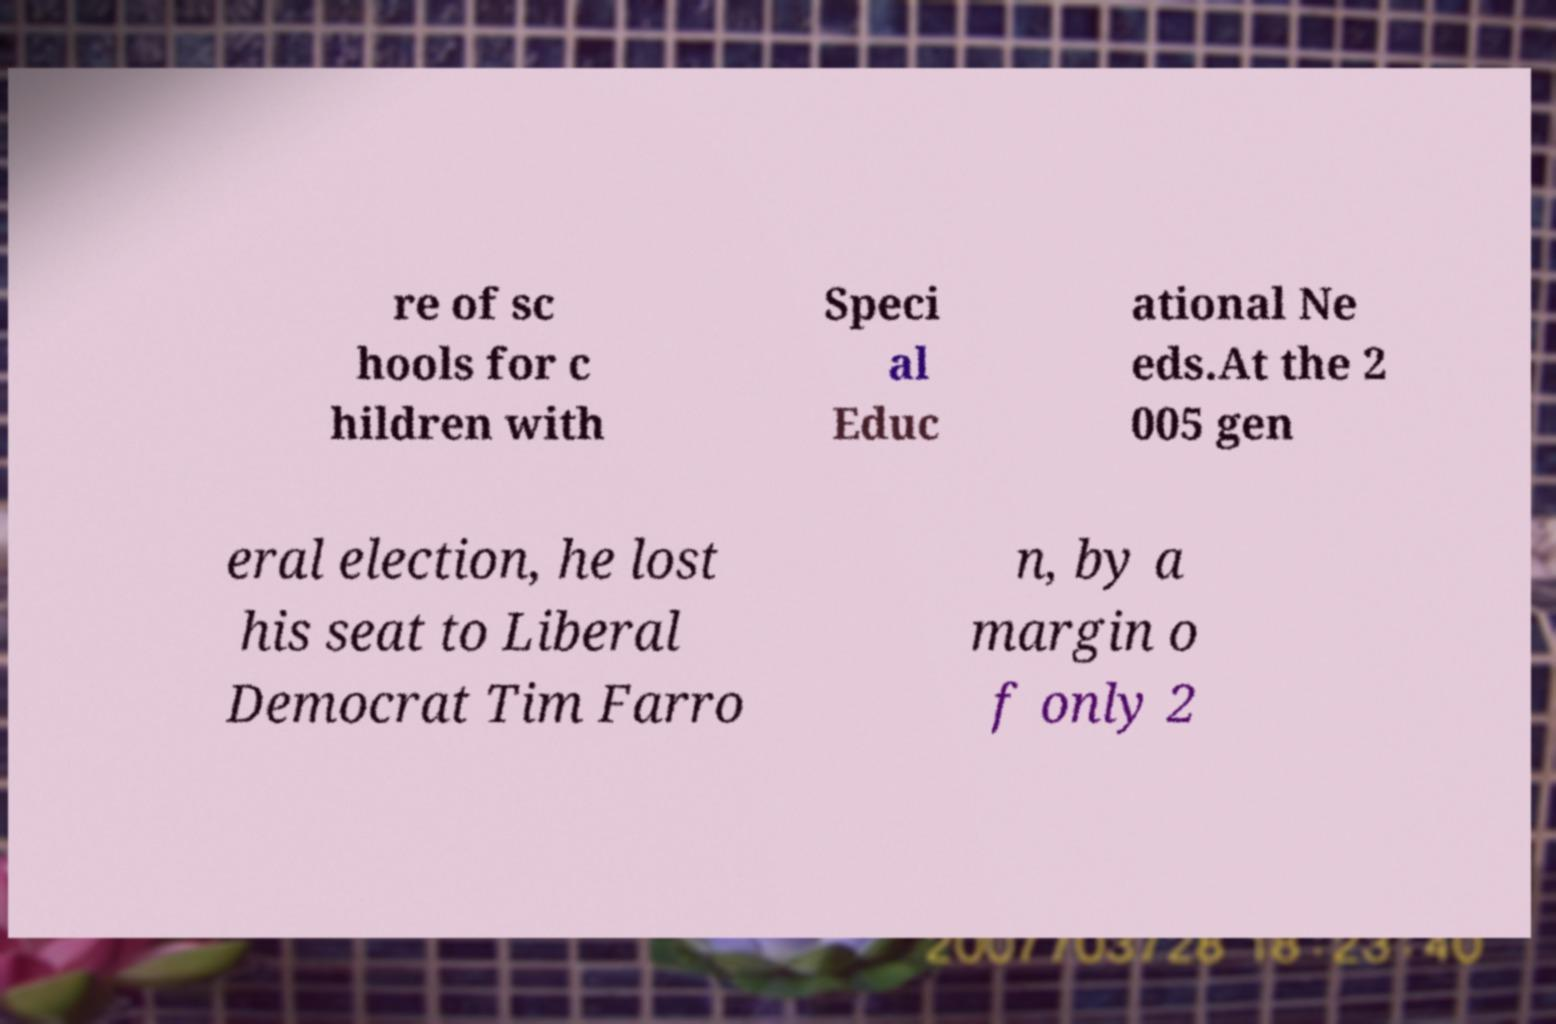Can you read and provide the text displayed in the image?This photo seems to have some interesting text. Can you extract and type it out for me? re of sc hools for c hildren with Speci al Educ ational Ne eds.At the 2 005 gen eral election, he lost his seat to Liberal Democrat Tim Farro n, by a margin o f only 2 